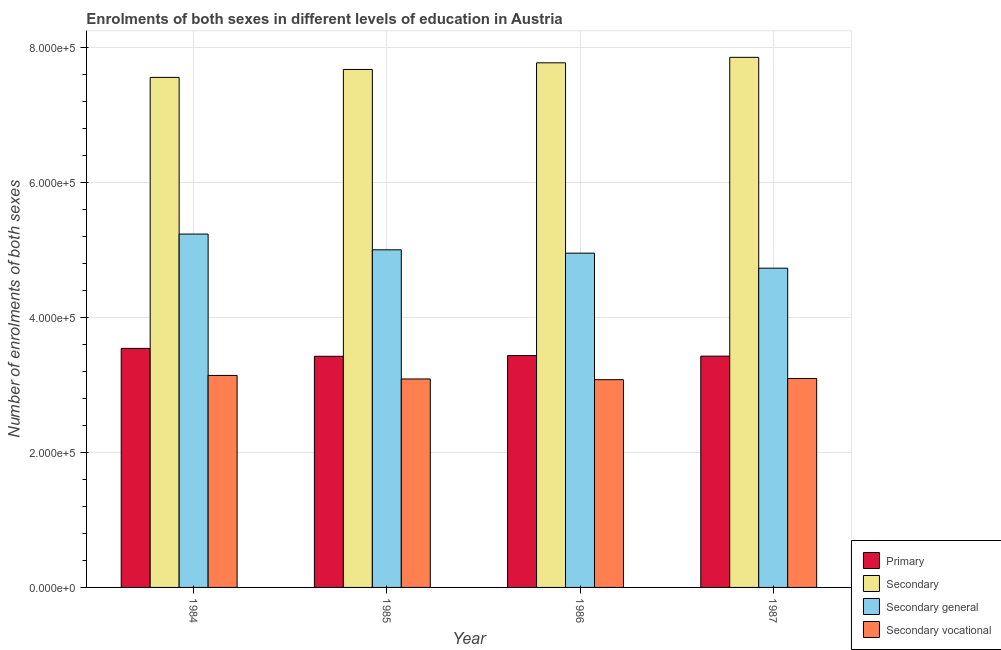How many different coloured bars are there?
Provide a short and direct response. 4. How many groups of bars are there?
Offer a very short reply. 4. In how many cases, is the number of bars for a given year not equal to the number of legend labels?
Make the answer very short. 0. What is the number of enrolments in secondary general education in 1987?
Provide a succinct answer. 4.73e+05. Across all years, what is the maximum number of enrolments in secondary education?
Ensure brevity in your answer.  7.86e+05. Across all years, what is the minimum number of enrolments in secondary education?
Ensure brevity in your answer.  7.56e+05. What is the total number of enrolments in secondary general education in the graph?
Provide a short and direct response. 1.99e+06. What is the difference between the number of enrolments in primary education in 1984 and that in 1986?
Your answer should be compact. 1.07e+04. What is the difference between the number of enrolments in secondary education in 1986 and the number of enrolments in primary education in 1987?
Ensure brevity in your answer.  -8150. What is the average number of enrolments in secondary vocational education per year?
Offer a terse response. 3.10e+05. In the year 1987, what is the difference between the number of enrolments in secondary education and number of enrolments in secondary general education?
Provide a short and direct response. 0. What is the ratio of the number of enrolments in primary education in 1985 to that in 1987?
Offer a terse response. 1. Is the number of enrolments in secondary general education in 1984 less than that in 1987?
Offer a terse response. No. What is the difference between the highest and the second highest number of enrolments in secondary vocational education?
Offer a terse response. 4506. What is the difference between the highest and the lowest number of enrolments in primary education?
Keep it short and to the point. 1.17e+04. In how many years, is the number of enrolments in secondary vocational education greater than the average number of enrolments in secondary vocational education taken over all years?
Your answer should be very brief. 1. Is it the case that in every year, the sum of the number of enrolments in primary education and number of enrolments in secondary vocational education is greater than the sum of number of enrolments in secondary general education and number of enrolments in secondary education?
Make the answer very short. No. What does the 4th bar from the left in 1986 represents?
Ensure brevity in your answer.  Secondary vocational. What does the 2nd bar from the right in 1987 represents?
Provide a short and direct response. Secondary general. Is it the case that in every year, the sum of the number of enrolments in primary education and number of enrolments in secondary education is greater than the number of enrolments in secondary general education?
Your answer should be very brief. Yes. How many bars are there?
Provide a short and direct response. 16. Are all the bars in the graph horizontal?
Ensure brevity in your answer.  No. What is the difference between two consecutive major ticks on the Y-axis?
Provide a succinct answer. 2.00e+05. Are the values on the major ticks of Y-axis written in scientific E-notation?
Your response must be concise. Yes. Does the graph contain grids?
Offer a very short reply. Yes. How are the legend labels stacked?
Your answer should be compact. Vertical. What is the title of the graph?
Keep it short and to the point. Enrolments of both sexes in different levels of education in Austria. What is the label or title of the X-axis?
Ensure brevity in your answer.  Year. What is the label or title of the Y-axis?
Offer a very short reply. Number of enrolments of both sexes. What is the Number of enrolments of both sexes in Primary in 1984?
Give a very brief answer. 3.54e+05. What is the Number of enrolments of both sexes of Secondary in 1984?
Offer a very short reply. 7.56e+05. What is the Number of enrolments of both sexes of Secondary general in 1984?
Your response must be concise. 5.24e+05. What is the Number of enrolments of both sexes in Secondary vocational in 1984?
Provide a succinct answer. 3.14e+05. What is the Number of enrolments of both sexes of Primary in 1985?
Ensure brevity in your answer.  3.43e+05. What is the Number of enrolments of both sexes of Secondary in 1985?
Ensure brevity in your answer.  7.68e+05. What is the Number of enrolments of both sexes in Secondary general in 1985?
Provide a succinct answer. 5.01e+05. What is the Number of enrolments of both sexes in Secondary vocational in 1985?
Your response must be concise. 3.09e+05. What is the Number of enrolments of both sexes of Primary in 1986?
Ensure brevity in your answer.  3.44e+05. What is the Number of enrolments of both sexes in Secondary in 1986?
Keep it short and to the point. 7.78e+05. What is the Number of enrolments of both sexes in Secondary general in 1986?
Keep it short and to the point. 4.96e+05. What is the Number of enrolments of both sexes of Secondary vocational in 1986?
Offer a terse response. 3.08e+05. What is the Number of enrolments of both sexes of Primary in 1987?
Your answer should be compact. 3.43e+05. What is the Number of enrolments of both sexes of Secondary in 1987?
Offer a terse response. 7.86e+05. What is the Number of enrolments of both sexes of Secondary general in 1987?
Offer a terse response. 4.73e+05. What is the Number of enrolments of both sexes in Secondary vocational in 1987?
Your answer should be very brief. 3.10e+05. Across all years, what is the maximum Number of enrolments of both sexes of Primary?
Provide a short and direct response. 3.54e+05. Across all years, what is the maximum Number of enrolments of both sexes in Secondary?
Make the answer very short. 7.86e+05. Across all years, what is the maximum Number of enrolments of both sexes in Secondary general?
Your response must be concise. 5.24e+05. Across all years, what is the maximum Number of enrolments of both sexes in Secondary vocational?
Provide a succinct answer. 3.14e+05. Across all years, what is the minimum Number of enrolments of both sexes in Primary?
Keep it short and to the point. 3.43e+05. Across all years, what is the minimum Number of enrolments of both sexes in Secondary?
Your response must be concise. 7.56e+05. Across all years, what is the minimum Number of enrolments of both sexes of Secondary general?
Offer a terse response. 4.73e+05. Across all years, what is the minimum Number of enrolments of both sexes in Secondary vocational?
Provide a succinct answer. 3.08e+05. What is the total Number of enrolments of both sexes of Primary in the graph?
Your response must be concise. 1.38e+06. What is the total Number of enrolments of both sexes in Secondary in the graph?
Offer a terse response. 3.09e+06. What is the total Number of enrolments of both sexes in Secondary general in the graph?
Your answer should be compact. 1.99e+06. What is the total Number of enrolments of both sexes in Secondary vocational in the graph?
Your answer should be very brief. 1.24e+06. What is the difference between the Number of enrolments of both sexes in Primary in 1984 and that in 1985?
Make the answer very short. 1.17e+04. What is the difference between the Number of enrolments of both sexes of Secondary in 1984 and that in 1985?
Offer a very short reply. -1.18e+04. What is the difference between the Number of enrolments of both sexes of Secondary general in 1984 and that in 1985?
Make the answer very short. 2.34e+04. What is the difference between the Number of enrolments of both sexes in Secondary vocational in 1984 and that in 1985?
Offer a terse response. 5224. What is the difference between the Number of enrolments of both sexes in Primary in 1984 and that in 1986?
Your answer should be very brief. 1.07e+04. What is the difference between the Number of enrolments of both sexes in Secondary in 1984 and that in 1986?
Ensure brevity in your answer.  -2.16e+04. What is the difference between the Number of enrolments of both sexes of Secondary general in 1984 and that in 1986?
Keep it short and to the point. 2.83e+04. What is the difference between the Number of enrolments of both sexes of Secondary vocational in 1984 and that in 1986?
Make the answer very short. 6298. What is the difference between the Number of enrolments of both sexes in Primary in 1984 and that in 1987?
Your response must be concise. 1.15e+04. What is the difference between the Number of enrolments of both sexes in Secondary in 1984 and that in 1987?
Provide a succinct answer. -2.98e+04. What is the difference between the Number of enrolments of both sexes of Secondary general in 1984 and that in 1987?
Provide a short and direct response. 5.06e+04. What is the difference between the Number of enrolments of both sexes of Secondary vocational in 1984 and that in 1987?
Your answer should be very brief. 4506. What is the difference between the Number of enrolments of both sexes of Primary in 1985 and that in 1986?
Make the answer very short. -1044. What is the difference between the Number of enrolments of both sexes of Secondary in 1985 and that in 1986?
Your answer should be compact. -9830. What is the difference between the Number of enrolments of both sexes of Secondary general in 1985 and that in 1986?
Your response must be concise. 4947. What is the difference between the Number of enrolments of both sexes in Secondary vocational in 1985 and that in 1986?
Offer a very short reply. 1074. What is the difference between the Number of enrolments of both sexes in Primary in 1985 and that in 1987?
Give a very brief answer. -234. What is the difference between the Number of enrolments of both sexes of Secondary in 1985 and that in 1987?
Offer a terse response. -1.80e+04. What is the difference between the Number of enrolments of both sexes of Secondary general in 1985 and that in 1987?
Your answer should be compact. 2.72e+04. What is the difference between the Number of enrolments of both sexes of Secondary vocational in 1985 and that in 1987?
Your answer should be compact. -718. What is the difference between the Number of enrolments of both sexes in Primary in 1986 and that in 1987?
Your answer should be compact. 810. What is the difference between the Number of enrolments of both sexes of Secondary in 1986 and that in 1987?
Provide a short and direct response. -8150. What is the difference between the Number of enrolments of both sexes in Secondary general in 1986 and that in 1987?
Your answer should be very brief. 2.23e+04. What is the difference between the Number of enrolments of both sexes in Secondary vocational in 1986 and that in 1987?
Make the answer very short. -1792. What is the difference between the Number of enrolments of both sexes of Primary in 1984 and the Number of enrolments of both sexes of Secondary in 1985?
Your answer should be very brief. -4.14e+05. What is the difference between the Number of enrolments of both sexes of Primary in 1984 and the Number of enrolments of both sexes of Secondary general in 1985?
Your answer should be very brief. -1.46e+05. What is the difference between the Number of enrolments of both sexes of Primary in 1984 and the Number of enrolments of both sexes of Secondary vocational in 1985?
Your response must be concise. 4.53e+04. What is the difference between the Number of enrolments of both sexes of Secondary in 1984 and the Number of enrolments of both sexes of Secondary general in 1985?
Your answer should be compact. 2.56e+05. What is the difference between the Number of enrolments of both sexes of Secondary in 1984 and the Number of enrolments of both sexes of Secondary vocational in 1985?
Provide a succinct answer. 4.47e+05. What is the difference between the Number of enrolments of both sexes in Secondary general in 1984 and the Number of enrolments of both sexes in Secondary vocational in 1985?
Your answer should be very brief. 2.15e+05. What is the difference between the Number of enrolments of both sexes in Primary in 1984 and the Number of enrolments of both sexes in Secondary in 1986?
Give a very brief answer. -4.24e+05. What is the difference between the Number of enrolments of both sexes of Primary in 1984 and the Number of enrolments of both sexes of Secondary general in 1986?
Offer a terse response. -1.41e+05. What is the difference between the Number of enrolments of both sexes of Primary in 1984 and the Number of enrolments of both sexes of Secondary vocational in 1986?
Your answer should be compact. 4.64e+04. What is the difference between the Number of enrolments of both sexes in Secondary in 1984 and the Number of enrolments of both sexes in Secondary general in 1986?
Your answer should be very brief. 2.61e+05. What is the difference between the Number of enrolments of both sexes in Secondary in 1984 and the Number of enrolments of both sexes in Secondary vocational in 1986?
Keep it short and to the point. 4.48e+05. What is the difference between the Number of enrolments of both sexes of Secondary general in 1984 and the Number of enrolments of both sexes of Secondary vocational in 1986?
Keep it short and to the point. 2.16e+05. What is the difference between the Number of enrolments of both sexes in Primary in 1984 and the Number of enrolments of both sexes in Secondary in 1987?
Your answer should be compact. -4.32e+05. What is the difference between the Number of enrolments of both sexes of Primary in 1984 and the Number of enrolments of both sexes of Secondary general in 1987?
Your answer should be compact. -1.19e+05. What is the difference between the Number of enrolments of both sexes of Primary in 1984 and the Number of enrolments of both sexes of Secondary vocational in 1987?
Offer a terse response. 4.46e+04. What is the difference between the Number of enrolments of both sexes of Secondary in 1984 and the Number of enrolments of both sexes of Secondary general in 1987?
Your answer should be very brief. 2.83e+05. What is the difference between the Number of enrolments of both sexes of Secondary in 1984 and the Number of enrolments of both sexes of Secondary vocational in 1987?
Provide a short and direct response. 4.47e+05. What is the difference between the Number of enrolments of both sexes in Secondary general in 1984 and the Number of enrolments of both sexes in Secondary vocational in 1987?
Offer a terse response. 2.14e+05. What is the difference between the Number of enrolments of both sexes of Primary in 1985 and the Number of enrolments of both sexes of Secondary in 1986?
Keep it short and to the point. -4.35e+05. What is the difference between the Number of enrolments of both sexes of Primary in 1985 and the Number of enrolments of both sexes of Secondary general in 1986?
Provide a succinct answer. -1.53e+05. What is the difference between the Number of enrolments of both sexes in Primary in 1985 and the Number of enrolments of both sexes in Secondary vocational in 1986?
Your response must be concise. 3.47e+04. What is the difference between the Number of enrolments of both sexes of Secondary in 1985 and the Number of enrolments of both sexes of Secondary general in 1986?
Your answer should be compact. 2.72e+05. What is the difference between the Number of enrolments of both sexes in Secondary in 1985 and the Number of enrolments of both sexes in Secondary vocational in 1986?
Your answer should be compact. 4.60e+05. What is the difference between the Number of enrolments of both sexes in Secondary general in 1985 and the Number of enrolments of both sexes in Secondary vocational in 1986?
Provide a short and direct response. 1.93e+05. What is the difference between the Number of enrolments of both sexes of Primary in 1985 and the Number of enrolments of both sexes of Secondary in 1987?
Your response must be concise. -4.43e+05. What is the difference between the Number of enrolments of both sexes of Primary in 1985 and the Number of enrolments of both sexes of Secondary general in 1987?
Give a very brief answer. -1.31e+05. What is the difference between the Number of enrolments of both sexes of Primary in 1985 and the Number of enrolments of both sexes of Secondary vocational in 1987?
Give a very brief answer. 3.29e+04. What is the difference between the Number of enrolments of both sexes in Secondary in 1985 and the Number of enrolments of both sexes in Secondary general in 1987?
Make the answer very short. 2.95e+05. What is the difference between the Number of enrolments of both sexes of Secondary in 1985 and the Number of enrolments of both sexes of Secondary vocational in 1987?
Your answer should be compact. 4.58e+05. What is the difference between the Number of enrolments of both sexes of Secondary general in 1985 and the Number of enrolments of both sexes of Secondary vocational in 1987?
Provide a short and direct response. 1.91e+05. What is the difference between the Number of enrolments of both sexes in Primary in 1986 and the Number of enrolments of both sexes in Secondary in 1987?
Make the answer very short. -4.42e+05. What is the difference between the Number of enrolments of both sexes in Primary in 1986 and the Number of enrolments of both sexes in Secondary general in 1987?
Ensure brevity in your answer.  -1.30e+05. What is the difference between the Number of enrolments of both sexes of Primary in 1986 and the Number of enrolments of both sexes of Secondary vocational in 1987?
Your answer should be compact. 3.39e+04. What is the difference between the Number of enrolments of both sexes of Secondary in 1986 and the Number of enrolments of both sexes of Secondary general in 1987?
Provide a short and direct response. 3.05e+05. What is the difference between the Number of enrolments of both sexes in Secondary in 1986 and the Number of enrolments of both sexes in Secondary vocational in 1987?
Your answer should be compact. 4.68e+05. What is the difference between the Number of enrolments of both sexes of Secondary general in 1986 and the Number of enrolments of both sexes of Secondary vocational in 1987?
Your answer should be compact. 1.86e+05. What is the average Number of enrolments of both sexes of Primary per year?
Make the answer very short. 3.46e+05. What is the average Number of enrolments of both sexes in Secondary per year?
Your response must be concise. 7.72e+05. What is the average Number of enrolments of both sexes in Secondary general per year?
Ensure brevity in your answer.  4.98e+05. What is the average Number of enrolments of both sexes of Secondary vocational per year?
Make the answer very short. 3.10e+05. In the year 1984, what is the difference between the Number of enrolments of both sexes of Primary and Number of enrolments of both sexes of Secondary?
Your answer should be very brief. -4.02e+05. In the year 1984, what is the difference between the Number of enrolments of both sexes of Primary and Number of enrolments of both sexes of Secondary general?
Offer a terse response. -1.70e+05. In the year 1984, what is the difference between the Number of enrolments of both sexes of Primary and Number of enrolments of both sexes of Secondary vocational?
Offer a terse response. 4.01e+04. In the year 1984, what is the difference between the Number of enrolments of both sexes of Secondary and Number of enrolments of both sexes of Secondary general?
Give a very brief answer. 2.32e+05. In the year 1984, what is the difference between the Number of enrolments of both sexes in Secondary and Number of enrolments of both sexes in Secondary vocational?
Give a very brief answer. 4.42e+05. In the year 1984, what is the difference between the Number of enrolments of both sexes in Secondary general and Number of enrolments of both sexes in Secondary vocational?
Offer a very short reply. 2.10e+05. In the year 1985, what is the difference between the Number of enrolments of both sexes of Primary and Number of enrolments of both sexes of Secondary?
Offer a very short reply. -4.25e+05. In the year 1985, what is the difference between the Number of enrolments of both sexes of Primary and Number of enrolments of both sexes of Secondary general?
Keep it short and to the point. -1.58e+05. In the year 1985, what is the difference between the Number of enrolments of both sexes of Primary and Number of enrolments of both sexes of Secondary vocational?
Give a very brief answer. 3.36e+04. In the year 1985, what is the difference between the Number of enrolments of both sexes of Secondary and Number of enrolments of both sexes of Secondary general?
Provide a succinct answer. 2.67e+05. In the year 1985, what is the difference between the Number of enrolments of both sexes of Secondary and Number of enrolments of both sexes of Secondary vocational?
Keep it short and to the point. 4.59e+05. In the year 1985, what is the difference between the Number of enrolments of both sexes in Secondary general and Number of enrolments of both sexes in Secondary vocational?
Provide a succinct answer. 1.92e+05. In the year 1986, what is the difference between the Number of enrolments of both sexes of Primary and Number of enrolments of both sexes of Secondary?
Offer a terse response. -4.34e+05. In the year 1986, what is the difference between the Number of enrolments of both sexes of Primary and Number of enrolments of both sexes of Secondary general?
Keep it short and to the point. -1.52e+05. In the year 1986, what is the difference between the Number of enrolments of both sexes of Primary and Number of enrolments of both sexes of Secondary vocational?
Keep it short and to the point. 3.57e+04. In the year 1986, what is the difference between the Number of enrolments of both sexes in Secondary and Number of enrolments of both sexes in Secondary general?
Ensure brevity in your answer.  2.82e+05. In the year 1986, what is the difference between the Number of enrolments of both sexes in Secondary and Number of enrolments of both sexes in Secondary vocational?
Your answer should be compact. 4.70e+05. In the year 1986, what is the difference between the Number of enrolments of both sexes of Secondary general and Number of enrolments of both sexes of Secondary vocational?
Provide a short and direct response. 1.88e+05. In the year 1987, what is the difference between the Number of enrolments of both sexes of Primary and Number of enrolments of both sexes of Secondary?
Make the answer very short. -4.43e+05. In the year 1987, what is the difference between the Number of enrolments of both sexes in Primary and Number of enrolments of both sexes in Secondary general?
Offer a very short reply. -1.30e+05. In the year 1987, what is the difference between the Number of enrolments of both sexes in Primary and Number of enrolments of both sexes in Secondary vocational?
Your answer should be very brief. 3.31e+04. In the year 1987, what is the difference between the Number of enrolments of both sexes of Secondary and Number of enrolments of both sexes of Secondary general?
Offer a very short reply. 3.13e+05. In the year 1987, what is the difference between the Number of enrolments of both sexes of Secondary and Number of enrolments of both sexes of Secondary vocational?
Your response must be concise. 4.76e+05. In the year 1987, what is the difference between the Number of enrolments of both sexes of Secondary general and Number of enrolments of both sexes of Secondary vocational?
Make the answer very short. 1.64e+05. What is the ratio of the Number of enrolments of both sexes of Primary in 1984 to that in 1985?
Your answer should be very brief. 1.03. What is the ratio of the Number of enrolments of both sexes of Secondary in 1984 to that in 1985?
Your answer should be very brief. 0.98. What is the ratio of the Number of enrolments of both sexes of Secondary general in 1984 to that in 1985?
Give a very brief answer. 1.05. What is the ratio of the Number of enrolments of both sexes of Secondary vocational in 1984 to that in 1985?
Your answer should be compact. 1.02. What is the ratio of the Number of enrolments of both sexes in Primary in 1984 to that in 1986?
Your answer should be compact. 1.03. What is the ratio of the Number of enrolments of both sexes in Secondary in 1984 to that in 1986?
Your answer should be very brief. 0.97. What is the ratio of the Number of enrolments of both sexes in Secondary general in 1984 to that in 1986?
Provide a succinct answer. 1.06. What is the ratio of the Number of enrolments of both sexes of Secondary vocational in 1984 to that in 1986?
Give a very brief answer. 1.02. What is the ratio of the Number of enrolments of both sexes in Primary in 1984 to that in 1987?
Offer a terse response. 1.03. What is the ratio of the Number of enrolments of both sexes of Secondary in 1984 to that in 1987?
Provide a short and direct response. 0.96. What is the ratio of the Number of enrolments of both sexes in Secondary general in 1984 to that in 1987?
Your answer should be compact. 1.11. What is the ratio of the Number of enrolments of both sexes in Secondary vocational in 1984 to that in 1987?
Your response must be concise. 1.01. What is the ratio of the Number of enrolments of both sexes of Primary in 1985 to that in 1986?
Your answer should be very brief. 1. What is the ratio of the Number of enrolments of both sexes in Secondary in 1985 to that in 1986?
Provide a succinct answer. 0.99. What is the ratio of the Number of enrolments of both sexes of Secondary general in 1985 to that in 1986?
Make the answer very short. 1.01. What is the ratio of the Number of enrolments of both sexes in Secondary vocational in 1985 to that in 1986?
Make the answer very short. 1. What is the ratio of the Number of enrolments of both sexes in Primary in 1985 to that in 1987?
Your answer should be compact. 1. What is the ratio of the Number of enrolments of both sexes of Secondary in 1985 to that in 1987?
Offer a very short reply. 0.98. What is the ratio of the Number of enrolments of both sexes in Secondary general in 1985 to that in 1987?
Your answer should be compact. 1.06. What is the ratio of the Number of enrolments of both sexes of Primary in 1986 to that in 1987?
Offer a terse response. 1. What is the ratio of the Number of enrolments of both sexes of Secondary general in 1986 to that in 1987?
Ensure brevity in your answer.  1.05. What is the difference between the highest and the second highest Number of enrolments of both sexes in Primary?
Your answer should be very brief. 1.07e+04. What is the difference between the highest and the second highest Number of enrolments of both sexes in Secondary?
Provide a succinct answer. 8150. What is the difference between the highest and the second highest Number of enrolments of both sexes of Secondary general?
Make the answer very short. 2.34e+04. What is the difference between the highest and the second highest Number of enrolments of both sexes of Secondary vocational?
Offer a very short reply. 4506. What is the difference between the highest and the lowest Number of enrolments of both sexes in Primary?
Your answer should be very brief. 1.17e+04. What is the difference between the highest and the lowest Number of enrolments of both sexes in Secondary?
Keep it short and to the point. 2.98e+04. What is the difference between the highest and the lowest Number of enrolments of both sexes in Secondary general?
Your response must be concise. 5.06e+04. What is the difference between the highest and the lowest Number of enrolments of both sexes of Secondary vocational?
Provide a succinct answer. 6298. 